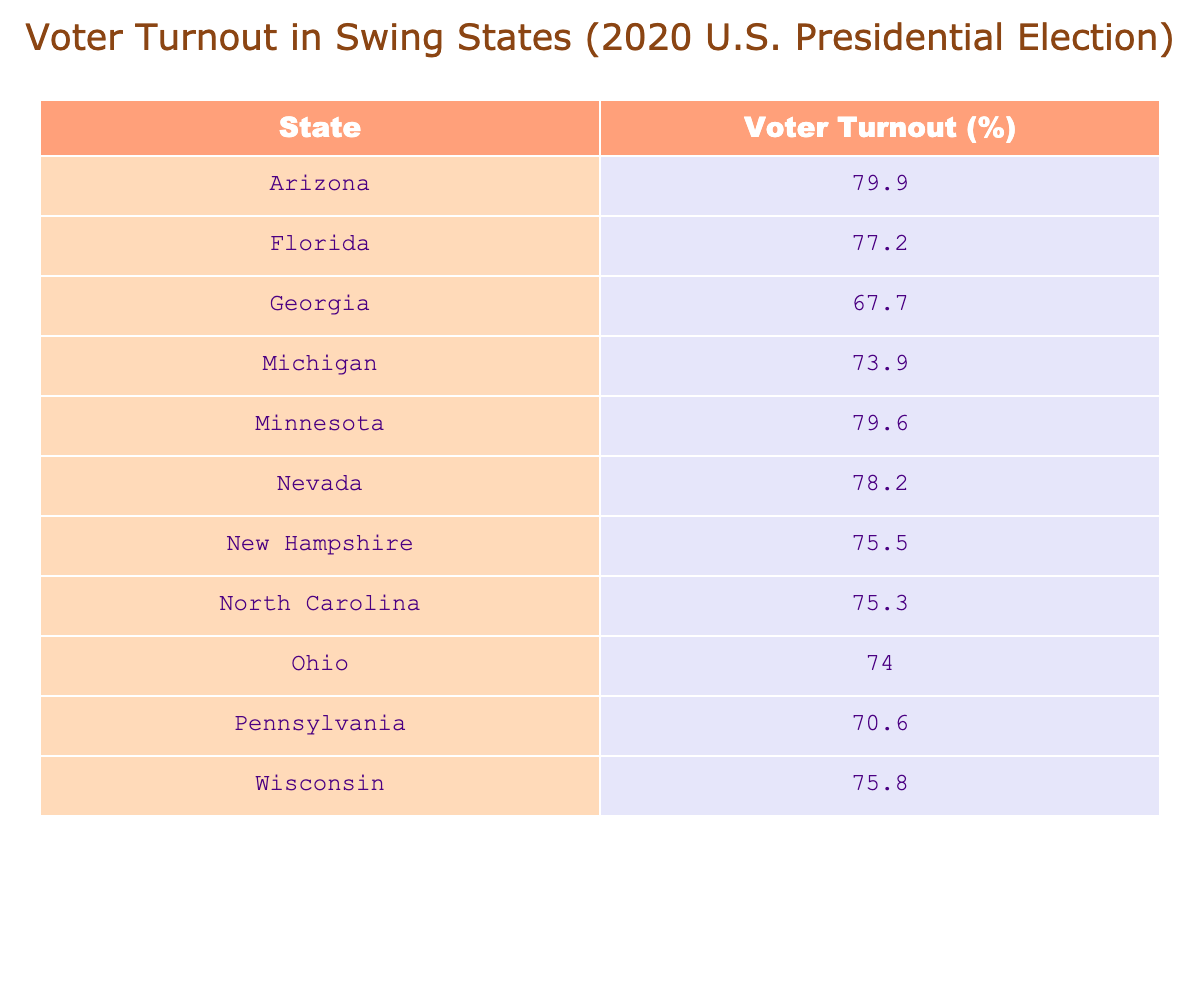What is the voter turnout percentage in Georgia? The table shows that Georgia has a voter turnout of 67.7%.
Answer: 67.7% Which state has the highest voter turnout rate? According to the table, Arizona has the highest voter turnout rate at 79.9%.
Answer: Arizona What is the average voter turnout percentage for all the states listed? To find the average, we sum the voter turnout percentages: (79.9 + 77.2 + 67.7 + 73.9 + 79.6 + 78.2 + 75.5 + 75.3 + 74.0 + 70.6 + 75.8) =  64.96, divided by the number of states (11) gives an average of approximately 75.6.
Answer: 75.6 Is the voter turnout in Nevada greater than that in Pennsylvania? The table shows Nevada has a turnout of 78.2% and Pennsylvania has 70.6%. Since 78.2% is greater than 70.6%, the answer is yes.
Answer: Yes How many states have a voter turnout percentage above 75%? We can check each state: Arizona, Florida, Minnesota, Nevada, New Hampshire, North Carolina, and Wisconsin all have above 75%. This totals to 7 states.
Answer: 7 What is the difference in voter turnout between Florida and Michigan? Florida has a voter turnout of 77.2% and Michigan has 73.9%. The difference is 77.2 - 73.9 = 3.3%.
Answer: 3.3% Which states have a voter turnout percentage below 70%? By checking the table, only Georgia (67.7%) and Pennsylvania (70.6%) have percentages below 70%.
Answer: Georgia If we exclude the lowest voter turnout rate, what is the average of the remaining states? The lowest turnout is Georgia at 67.7%. Removing this from the total of 11 states, we sum the remaining rates (79.9 + 77.2 + 73.9 + 79.6 + 78.2 + 75.5 + 75.3 + 74.0 + 70.6 + 75.8) =  79.96. Dividing by 10 gives an average of approximately 76.0%.
Answer: 76.0 Are there any states with turnout rates within two percentage points of each other? Looking closely, New Hampshire (75.5%) and North Carolina (75.3%) are within 2 percentage points of each other.
Answer: Yes What is the total voter turnout percentage of the three states with the highest turnout? We summate the top three: Arizona (79.9%) + Minnesota (79.6%) + Nevada (78.2%) = 237.7%.
Answer: 237.7% 